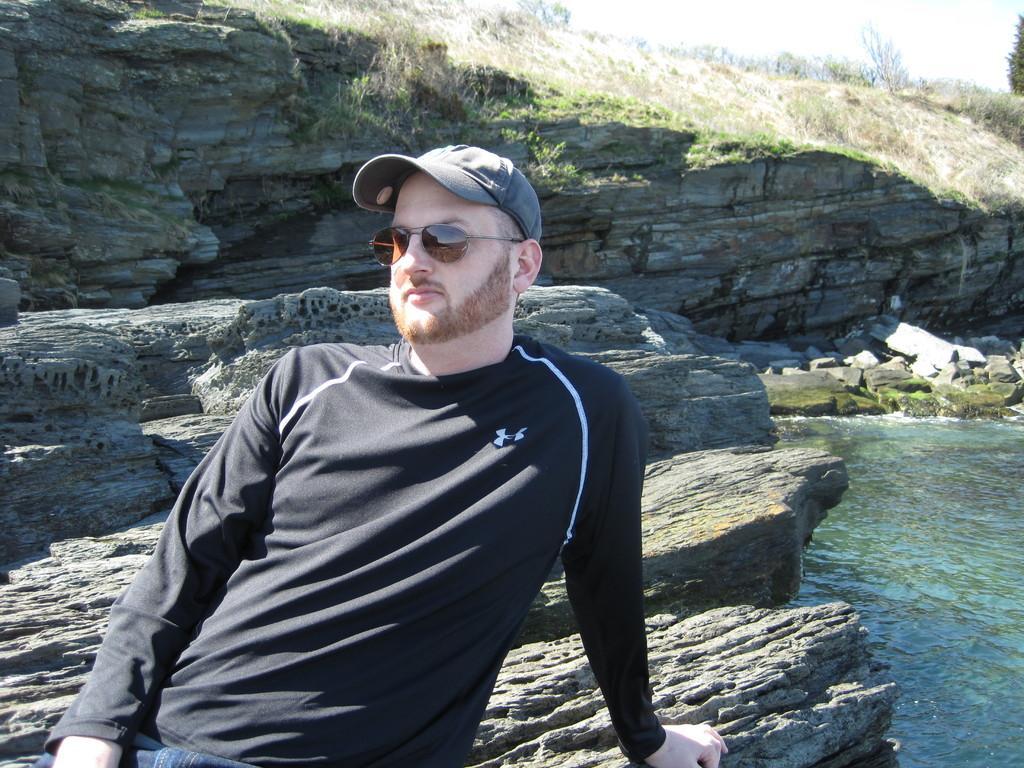How would you summarize this image in a sentence or two? Here in this picture we can see a person in a black colored t shirt present over a place and we can see he is wearing goggles and cap on him and he is keeping his hand on the rock stone present behind him all over there and we can see grass covered on the rock stones over there and on the right side we can see water present all over there and in the far we can see trees present. 